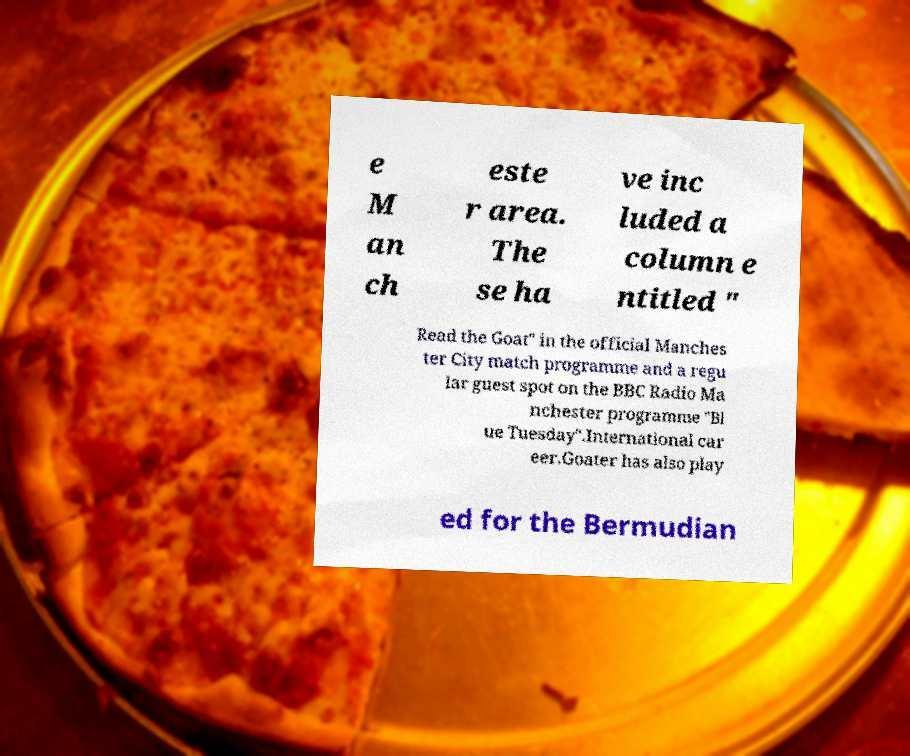Could you assist in decoding the text presented in this image and type it out clearly? e M an ch este r area. The se ha ve inc luded a column e ntitled " Read the Goat" in the official Manches ter City match programme and a regu lar guest spot on the BBC Radio Ma nchester programme "Bl ue Tuesday".International car eer.Goater has also play ed for the Bermudian 